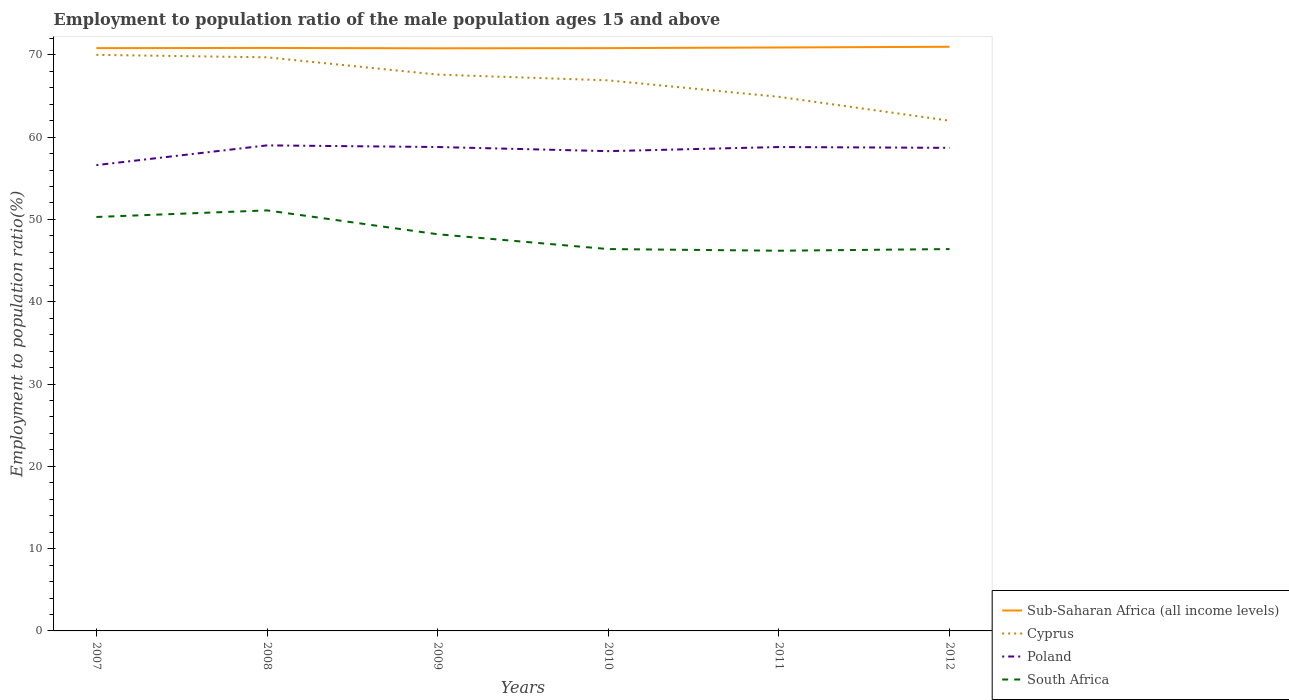How many different coloured lines are there?
Make the answer very short. 4. Is the number of lines equal to the number of legend labels?
Keep it short and to the point. Yes. Across all years, what is the maximum employment to population ratio in Poland?
Your response must be concise. 56.6. What is the total employment to population ratio in South Africa in the graph?
Keep it short and to the point. 4.7. What is the difference between the highest and the second highest employment to population ratio in Poland?
Your response must be concise. 2.4. What is the difference between the highest and the lowest employment to population ratio in Cyprus?
Your response must be concise. 4. Is the employment to population ratio in Sub-Saharan Africa (all income levels) strictly greater than the employment to population ratio in South Africa over the years?
Ensure brevity in your answer.  No. Does the graph contain any zero values?
Offer a terse response. No. Where does the legend appear in the graph?
Your response must be concise. Bottom right. How many legend labels are there?
Your answer should be compact. 4. What is the title of the graph?
Provide a succinct answer. Employment to population ratio of the male population ages 15 and above. What is the Employment to population ratio(%) in Sub-Saharan Africa (all income levels) in 2007?
Your response must be concise. 70.82. What is the Employment to population ratio(%) of Cyprus in 2007?
Make the answer very short. 70. What is the Employment to population ratio(%) of Poland in 2007?
Make the answer very short. 56.6. What is the Employment to population ratio(%) in South Africa in 2007?
Your response must be concise. 50.3. What is the Employment to population ratio(%) in Sub-Saharan Africa (all income levels) in 2008?
Keep it short and to the point. 70.84. What is the Employment to population ratio(%) of Cyprus in 2008?
Ensure brevity in your answer.  69.7. What is the Employment to population ratio(%) in Poland in 2008?
Your answer should be very brief. 59. What is the Employment to population ratio(%) in South Africa in 2008?
Provide a short and direct response. 51.1. What is the Employment to population ratio(%) in Sub-Saharan Africa (all income levels) in 2009?
Provide a short and direct response. 70.8. What is the Employment to population ratio(%) of Cyprus in 2009?
Your answer should be very brief. 67.6. What is the Employment to population ratio(%) of Poland in 2009?
Offer a very short reply. 58.8. What is the Employment to population ratio(%) in South Africa in 2009?
Give a very brief answer. 48.2. What is the Employment to population ratio(%) in Sub-Saharan Africa (all income levels) in 2010?
Offer a very short reply. 70.82. What is the Employment to population ratio(%) in Cyprus in 2010?
Provide a short and direct response. 66.9. What is the Employment to population ratio(%) in Poland in 2010?
Provide a short and direct response. 58.3. What is the Employment to population ratio(%) in South Africa in 2010?
Make the answer very short. 46.4. What is the Employment to population ratio(%) of Sub-Saharan Africa (all income levels) in 2011?
Make the answer very short. 70.9. What is the Employment to population ratio(%) in Cyprus in 2011?
Make the answer very short. 64.9. What is the Employment to population ratio(%) in Poland in 2011?
Offer a terse response. 58.8. What is the Employment to population ratio(%) in South Africa in 2011?
Make the answer very short. 46.2. What is the Employment to population ratio(%) in Sub-Saharan Africa (all income levels) in 2012?
Offer a very short reply. 70.98. What is the Employment to population ratio(%) in Poland in 2012?
Ensure brevity in your answer.  58.7. What is the Employment to population ratio(%) in South Africa in 2012?
Your answer should be compact. 46.4. Across all years, what is the maximum Employment to population ratio(%) of Sub-Saharan Africa (all income levels)?
Your answer should be compact. 70.98. Across all years, what is the maximum Employment to population ratio(%) in South Africa?
Provide a succinct answer. 51.1. Across all years, what is the minimum Employment to population ratio(%) of Sub-Saharan Africa (all income levels)?
Your answer should be compact. 70.8. Across all years, what is the minimum Employment to population ratio(%) of Poland?
Keep it short and to the point. 56.6. Across all years, what is the minimum Employment to population ratio(%) of South Africa?
Ensure brevity in your answer.  46.2. What is the total Employment to population ratio(%) in Sub-Saharan Africa (all income levels) in the graph?
Your response must be concise. 425.15. What is the total Employment to population ratio(%) in Cyprus in the graph?
Make the answer very short. 401.1. What is the total Employment to population ratio(%) of Poland in the graph?
Keep it short and to the point. 350.2. What is the total Employment to population ratio(%) of South Africa in the graph?
Ensure brevity in your answer.  288.6. What is the difference between the Employment to population ratio(%) of Sub-Saharan Africa (all income levels) in 2007 and that in 2008?
Make the answer very short. -0.02. What is the difference between the Employment to population ratio(%) of Cyprus in 2007 and that in 2008?
Your answer should be compact. 0.3. What is the difference between the Employment to population ratio(%) in Sub-Saharan Africa (all income levels) in 2007 and that in 2009?
Your response must be concise. 0.02. What is the difference between the Employment to population ratio(%) in Poland in 2007 and that in 2009?
Ensure brevity in your answer.  -2.2. What is the difference between the Employment to population ratio(%) of South Africa in 2007 and that in 2009?
Your answer should be compact. 2.1. What is the difference between the Employment to population ratio(%) of Sub-Saharan Africa (all income levels) in 2007 and that in 2010?
Give a very brief answer. -0. What is the difference between the Employment to population ratio(%) of Poland in 2007 and that in 2010?
Offer a very short reply. -1.7. What is the difference between the Employment to population ratio(%) in Sub-Saharan Africa (all income levels) in 2007 and that in 2011?
Provide a succinct answer. -0.08. What is the difference between the Employment to population ratio(%) in Cyprus in 2007 and that in 2011?
Provide a short and direct response. 5.1. What is the difference between the Employment to population ratio(%) in Poland in 2007 and that in 2011?
Make the answer very short. -2.2. What is the difference between the Employment to population ratio(%) of Sub-Saharan Africa (all income levels) in 2007 and that in 2012?
Offer a very short reply. -0.16. What is the difference between the Employment to population ratio(%) in Cyprus in 2007 and that in 2012?
Provide a succinct answer. 8. What is the difference between the Employment to population ratio(%) of Sub-Saharan Africa (all income levels) in 2008 and that in 2009?
Ensure brevity in your answer.  0.04. What is the difference between the Employment to population ratio(%) of South Africa in 2008 and that in 2009?
Offer a terse response. 2.9. What is the difference between the Employment to population ratio(%) of Sub-Saharan Africa (all income levels) in 2008 and that in 2010?
Your answer should be very brief. 0.02. What is the difference between the Employment to population ratio(%) of Cyprus in 2008 and that in 2010?
Ensure brevity in your answer.  2.8. What is the difference between the Employment to population ratio(%) in Poland in 2008 and that in 2010?
Make the answer very short. 0.7. What is the difference between the Employment to population ratio(%) of South Africa in 2008 and that in 2010?
Your response must be concise. 4.7. What is the difference between the Employment to population ratio(%) of Sub-Saharan Africa (all income levels) in 2008 and that in 2011?
Offer a terse response. -0.06. What is the difference between the Employment to population ratio(%) in Cyprus in 2008 and that in 2011?
Give a very brief answer. 4.8. What is the difference between the Employment to population ratio(%) in South Africa in 2008 and that in 2011?
Provide a succinct answer. 4.9. What is the difference between the Employment to population ratio(%) in Sub-Saharan Africa (all income levels) in 2008 and that in 2012?
Offer a terse response. -0.14. What is the difference between the Employment to population ratio(%) in Cyprus in 2008 and that in 2012?
Offer a very short reply. 7.7. What is the difference between the Employment to population ratio(%) in Poland in 2008 and that in 2012?
Your answer should be very brief. 0.3. What is the difference between the Employment to population ratio(%) of Sub-Saharan Africa (all income levels) in 2009 and that in 2010?
Give a very brief answer. -0.02. What is the difference between the Employment to population ratio(%) of Cyprus in 2009 and that in 2010?
Keep it short and to the point. 0.7. What is the difference between the Employment to population ratio(%) of Poland in 2009 and that in 2010?
Your answer should be compact. 0.5. What is the difference between the Employment to population ratio(%) in Sub-Saharan Africa (all income levels) in 2009 and that in 2011?
Provide a succinct answer. -0.1. What is the difference between the Employment to population ratio(%) of Cyprus in 2009 and that in 2011?
Give a very brief answer. 2.7. What is the difference between the Employment to population ratio(%) of Poland in 2009 and that in 2011?
Offer a very short reply. 0. What is the difference between the Employment to population ratio(%) of South Africa in 2009 and that in 2011?
Your answer should be compact. 2. What is the difference between the Employment to population ratio(%) of Sub-Saharan Africa (all income levels) in 2009 and that in 2012?
Offer a very short reply. -0.18. What is the difference between the Employment to population ratio(%) of Cyprus in 2009 and that in 2012?
Offer a very short reply. 5.6. What is the difference between the Employment to population ratio(%) in Poland in 2009 and that in 2012?
Your response must be concise. 0.1. What is the difference between the Employment to population ratio(%) of Sub-Saharan Africa (all income levels) in 2010 and that in 2011?
Your answer should be compact. -0.08. What is the difference between the Employment to population ratio(%) in Poland in 2010 and that in 2011?
Ensure brevity in your answer.  -0.5. What is the difference between the Employment to population ratio(%) in South Africa in 2010 and that in 2011?
Give a very brief answer. 0.2. What is the difference between the Employment to population ratio(%) in Sub-Saharan Africa (all income levels) in 2010 and that in 2012?
Give a very brief answer. -0.16. What is the difference between the Employment to population ratio(%) of Cyprus in 2010 and that in 2012?
Your response must be concise. 4.9. What is the difference between the Employment to population ratio(%) of Poland in 2010 and that in 2012?
Offer a very short reply. -0.4. What is the difference between the Employment to population ratio(%) of South Africa in 2010 and that in 2012?
Make the answer very short. 0. What is the difference between the Employment to population ratio(%) of Sub-Saharan Africa (all income levels) in 2011 and that in 2012?
Make the answer very short. -0.09. What is the difference between the Employment to population ratio(%) in Cyprus in 2011 and that in 2012?
Keep it short and to the point. 2.9. What is the difference between the Employment to population ratio(%) in Poland in 2011 and that in 2012?
Keep it short and to the point. 0.1. What is the difference between the Employment to population ratio(%) in Sub-Saharan Africa (all income levels) in 2007 and the Employment to population ratio(%) in Cyprus in 2008?
Offer a very short reply. 1.12. What is the difference between the Employment to population ratio(%) of Sub-Saharan Africa (all income levels) in 2007 and the Employment to population ratio(%) of Poland in 2008?
Make the answer very short. 11.82. What is the difference between the Employment to population ratio(%) in Sub-Saharan Africa (all income levels) in 2007 and the Employment to population ratio(%) in South Africa in 2008?
Provide a succinct answer. 19.72. What is the difference between the Employment to population ratio(%) in Poland in 2007 and the Employment to population ratio(%) in South Africa in 2008?
Give a very brief answer. 5.5. What is the difference between the Employment to population ratio(%) of Sub-Saharan Africa (all income levels) in 2007 and the Employment to population ratio(%) of Cyprus in 2009?
Offer a very short reply. 3.22. What is the difference between the Employment to population ratio(%) of Sub-Saharan Africa (all income levels) in 2007 and the Employment to population ratio(%) of Poland in 2009?
Provide a succinct answer. 12.02. What is the difference between the Employment to population ratio(%) in Sub-Saharan Africa (all income levels) in 2007 and the Employment to population ratio(%) in South Africa in 2009?
Give a very brief answer. 22.62. What is the difference between the Employment to population ratio(%) of Cyprus in 2007 and the Employment to population ratio(%) of South Africa in 2009?
Offer a very short reply. 21.8. What is the difference between the Employment to population ratio(%) in Sub-Saharan Africa (all income levels) in 2007 and the Employment to population ratio(%) in Cyprus in 2010?
Provide a short and direct response. 3.92. What is the difference between the Employment to population ratio(%) in Sub-Saharan Africa (all income levels) in 2007 and the Employment to population ratio(%) in Poland in 2010?
Your response must be concise. 12.52. What is the difference between the Employment to population ratio(%) in Sub-Saharan Africa (all income levels) in 2007 and the Employment to population ratio(%) in South Africa in 2010?
Make the answer very short. 24.42. What is the difference between the Employment to population ratio(%) in Cyprus in 2007 and the Employment to population ratio(%) in Poland in 2010?
Give a very brief answer. 11.7. What is the difference between the Employment to population ratio(%) of Cyprus in 2007 and the Employment to population ratio(%) of South Africa in 2010?
Make the answer very short. 23.6. What is the difference between the Employment to population ratio(%) of Poland in 2007 and the Employment to population ratio(%) of South Africa in 2010?
Provide a succinct answer. 10.2. What is the difference between the Employment to population ratio(%) in Sub-Saharan Africa (all income levels) in 2007 and the Employment to population ratio(%) in Cyprus in 2011?
Your answer should be very brief. 5.92. What is the difference between the Employment to population ratio(%) in Sub-Saharan Africa (all income levels) in 2007 and the Employment to population ratio(%) in Poland in 2011?
Your response must be concise. 12.02. What is the difference between the Employment to population ratio(%) in Sub-Saharan Africa (all income levels) in 2007 and the Employment to population ratio(%) in South Africa in 2011?
Your answer should be compact. 24.62. What is the difference between the Employment to population ratio(%) of Cyprus in 2007 and the Employment to population ratio(%) of South Africa in 2011?
Your answer should be compact. 23.8. What is the difference between the Employment to population ratio(%) in Sub-Saharan Africa (all income levels) in 2007 and the Employment to population ratio(%) in Cyprus in 2012?
Provide a succinct answer. 8.82. What is the difference between the Employment to population ratio(%) of Sub-Saharan Africa (all income levels) in 2007 and the Employment to population ratio(%) of Poland in 2012?
Provide a short and direct response. 12.12. What is the difference between the Employment to population ratio(%) in Sub-Saharan Africa (all income levels) in 2007 and the Employment to population ratio(%) in South Africa in 2012?
Offer a very short reply. 24.42. What is the difference between the Employment to population ratio(%) in Cyprus in 2007 and the Employment to population ratio(%) in South Africa in 2012?
Ensure brevity in your answer.  23.6. What is the difference between the Employment to population ratio(%) of Poland in 2007 and the Employment to population ratio(%) of South Africa in 2012?
Your answer should be very brief. 10.2. What is the difference between the Employment to population ratio(%) in Sub-Saharan Africa (all income levels) in 2008 and the Employment to population ratio(%) in Cyprus in 2009?
Make the answer very short. 3.24. What is the difference between the Employment to population ratio(%) in Sub-Saharan Africa (all income levels) in 2008 and the Employment to population ratio(%) in Poland in 2009?
Offer a very short reply. 12.04. What is the difference between the Employment to population ratio(%) in Sub-Saharan Africa (all income levels) in 2008 and the Employment to population ratio(%) in South Africa in 2009?
Your response must be concise. 22.64. What is the difference between the Employment to population ratio(%) in Cyprus in 2008 and the Employment to population ratio(%) in South Africa in 2009?
Keep it short and to the point. 21.5. What is the difference between the Employment to population ratio(%) of Sub-Saharan Africa (all income levels) in 2008 and the Employment to population ratio(%) of Cyprus in 2010?
Keep it short and to the point. 3.94. What is the difference between the Employment to population ratio(%) in Sub-Saharan Africa (all income levels) in 2008 and the Employment to population ratio(%) in Poland in 2010?
Provide a short and direct response. 12.54. What is the difference between the Employment to population ratio(%) in Sub-Saharan Africa (all income levels) in 2008 and the Employment to population ratio(%) in South Africa in 2010?
Your response must be concise. 24.44. What is the difference between the Employment to population ratio(%) of Cyprus in 2008 and the Employment to population ratio(%) of Poland in 2010?
Offer a very short reply. 11.4. What is the difference between the Employment to population ratio(%) in Cyprus in 2008 and the Employment to population ratio(%) in South Africa in 2010?
Your answer should be very brief. 23.3. What is the difference between the Employment to population ratio(%) of Poland in 2008 and the Employment to population ratio(%) of South Africa in 2010?
Your answer should be compact. 12.6. What is the difference between the Employment to population ratio(%) in Sub-Saharan Africa (all income levels) in 2008 and the Employment to population ratio(%) in Cyprus in 2011?
Your answer should be very brief. 5.94. What is the difference between the Employment to population ratio(%) of Sub-Saharan Africa (all income levels) in 2008 and the Employment to population ratio(%) of Poland in 2011?
Provide a succinct answer. 12.04. What is the difference between the Employment to population ratio(%) of Sub-Saharan Africa (all income levels) in 2008 and the Employment to population ratio(%) of South Africa in 2011?
Keep it short and to the point. 24.64. What is the difference between the Employment to population ratio(%) in Cyprus in 2008 and the Employment to population ratio(%) in Poland in 2011?
Make the answer very short. 10.9. What is the difference between the Employment to population ratio(%) in Sub-Saharan Africa (all income levels) in 2008 and the Employment to population ratio(%) in Cyprus in 2012?
Your answer should be very brief. 8.84. What is the difference between the Employment to population ratio(%) in Sub-Saharan Africa (all income levels) in 2008 and the Employment to population ratio(%) in Poland in 2012?
Ensure brevity in your answer.  12.14. What is the difference between the Employment to population ratio(%) in Sub-Saharan Africa (all income levels) in 2008 and the Employment to population ratio(%) in South Africa in 2012?
Give a very brief answer. 24.44. What is the difference between the Employment to population ratio(%) of Cyprus in 2008 and the Employment to population ratio(%) of Poland in 2012?
Keep it short and to the point. 11. What is the difference between the Employment to population ratio(%) in Cyprus in 2008 and the Employment to population ratio(%) in South Africa in 2012?
Provide a short and direct response. 23.3. What is the difference between the Employment to population ratio(%) of Poland in 2008 and the Employment to population ratio(%) of South Africa in 2012?
Your answer should be compact. 12.6. What is the difference between the Employment to population ratio(%) of Sub-Saharan Africa (all income levels) in 2009 and the Employment to population ratio(%) of Cyprus in 2010?
Your answer should be compact. 3.9. What is the difference between the Employment to population ratio(%) in Sub-Saharan Africa (all income levels) in 2009 and the Employment to population ratio(%) in Poland in 2010?
Your answer should be compact. 12.5. What is the difference between the Employment to population ratio(%) of Sub-Saharan Africa (all income levels) in 2009 and the Employment to population ratio(%) of South Africa in 2010?
Keep it short and to the point. 24.4. What is the difference between the Employment to population ratio(%) in Cyprus in 2009 and the Employment to population ratio(%) in Poland in 2010?
Keep it short and to the point. 9.3. What is the difference between the Employment to population ratio(%) of Cyprus in 2009 and the Employment to population ratio(%) of South Africa in 2010?
Your response must be concise. 21.2. What is the difference between the Employment to population ratio(%) in Poland in 2009 and the Employment to population ratio(%) in South Africa in 2010?
Provide a short and direct response. 12.4. What is the difference between the Employment to population ratio(%) in Sub-Saharan Africa (all income levels) in 2009 and the Employment to population ratio(%) in Cyprus in 2011?
Provide a succinct answer. 5.9. What is the difference between the Employment to population ratio(%) of Sub-Saharan Africa (all income levels) in 2009 and the Employment to population ratio(%) of Poland in 2011?
Keep it short and to the point. 12. What is the difference between the Employment to population ratio(%) in Sub-Saharan Africa (all income levels) in 2009 and the Employment to population ratio(%) in South Africa in 2011?
Your answer should be very brief. 24.6. What is the difference between the Employment to population ratio(%) in Cyprus in 2009 and the Employment to population ratio(%) in Poland in 2011?
Give a very brief answer. 8.8. What is the difference between the Employment to population ratio(%) in Cyprus in 2009 and the Employment to population ratio(%) in South Africa in 2011?
Keep it short and to the point. 21.4. What is the difference between the Employment to population ratio(%) of Sub-Saharan Africa (all income levels) in 2009 and the Employment to population ratio(%) of Cyprus in 2012?
Your answer should be very brief. 8.8. What is the difference between the Employment to population ratio(%) in Sub-Saharan Africa (all income levels) in 2009 and the Employment to population ratio(%) in Poland in 2012?
Provide a short and direct response. 12.1. What is the difference between the Employment to population ratio(%) of Sub-Saharan Africa (all income levels) in 2009 and the Employment to population ratio(%) of South Africa in 2012?
Your response must be concise. 24.4. What is the difference between the Employment to population ratio(%) in Cyprus in 2009 and the Employment to population ratio(%) in Poland in 2012?
Your answer should be compact. 8.9. What is the difference between the Employment to population ratio(%) in Cyprus in 2009 and the Employment to population ratio(%) in South Africa in 2012?
Give a very brief answer. 21.2. What is the difference between the Employment to population ratio(%) of Poland in 2009 and the Employment to population ratio(%) of South Africa in 2012?
Your answer should be very brief. 12.4. What is the difference between the Employment to population ratio(%) of Sub-Saharan Africa (all income levels) in 2010 and the Employment to population ratio(%) of Cyprus in 2011?
Offer a very short reply. 5.92. What is the difference between the Employment to population ratio(%) of Sub-Saharan Africa (all income levels) in 2010 and the Employment to population ratio(%) of Poland in 2011?
Provide a succinct answer. 12.02. What is the difference between the Employment to population ratio(%) of Sub-Saharan Africa (all income levels) in 2010 and the Employment to population ratio(%) of South Africa in 2011?
Offer a very short reply. 24.62. What is the difference between the Employment to population ratio(%) in Cyprus in 2010 and the Employment to population ratio(%) in Poland in 2011?
Your response must be concise. 8.1. What is the difference between the Employment to population ratio(%) in Cyprus in 2010 and the Employment to population ratio(%) in South Africa in 2011?
Your answer should be very brief. 20.7. What is the difference between the Employment to population ratio(%) in Sub-Saharan Africa (all income levels) in 2010 and the Employment to population ratio(%) in Cyprus in 2012?
Your answer should be very brief. 8.82. What is the difference between the Employment to population ratio(%) in Sub-Saharan Africa (all income levels) in 2010 and the Employment to population ratio(%) in Poland in 2012?
Provide a short and direct response. 12.12. What is the difference between the Employment to population ratio(%) in Sub-Saharan Africa (all income levels) in 2010 and the Employment to population ratio(%) in South Africa in 2012?
Offer a terse response. 24.42. What is the difference between the Employment to population ratio(%) of Poland in 2010 and the Employment to population ratio(%) of South Africa in 2012?
Provide a short and direct response. 11.9. What is the difference between the Employment to population ratio(%) in Sub-Saharan Africa (all income levels) in 2011 and the Employment to population ratio(%) in Cyprus in 2012?
Offer a very short reply. 8.9. What is the difference between the Employment to population ratio(%) of Sub-Saharan Africa (all income levels) in 2011 and the Employment to population ratio(%) of Poland in 2012?
Give a very brief answer. 12.2. What is the difference between the Employment to population ratio(%) in Sub-Saharan Africa (all income levels) in 2011 and the Employment to population ratio(%) in South Africa in 2012?
Your answer should be compact. 24.5. What is the average Employment to population ratio(%) in Sub-Saharan Africa (all income levels) per year?
Keep it short and to the point. 70.86. What is the average Employment to population ratio(%) in Cyprus per year?
Keep it short and to the point. 66.85. What is the average Employment to population ratio(%) in Poland per year?
Your answer should be compact. 58.37. What is the average Employment to population ratio(%) in South Africa per year?
Keep it short and to the point. 48.1. In the year 2007, what is the difference between the Employment to population ratio(%) in Sub-Saharan Africa (all income levels) and Employment to population ratio(%) in Cyprus?
Make the answer very short. 0.82. In the year 2007, what is the difference between the Employment to population ratio(%) of Sub-Saharan Africa (all income levels) and Employment to population ratio(%) of Poland?
Your response must be concise. 14.22. In the year 2007, what is the difference between the Employment to population ratio(%) of Sub-Saharan Africa (all income levels) and Employment to population ratio(%) of South Africa?
Provide a succinct answer. 20.52. In the year 2008, what is the difference between the Employment to population ratio(%) in Sub-Saharan Africa (all income levels) and Employment to population ratio(%) in Cyprus?
Your answer should be very brief. 1.14. In the year 2008, what is the difference between the Employment to population ratio(%) of Sub-Saharan Africa (all income levels) and Employment to population ratio(%) of Poland?
Your answer should be very brief. 11.84. In the year 2008, what is the difference between the Employment to population ratio(%) in Sub-Saharan Africa (all income levels) and Employment to population ratio(%) in South Africa?
Ensure brevity in your answer.  19.74. In the year 2008, what is the difference between the Employment to population ratio(%) of Cyprus and Employment to population ratio(%) of Poland?
Keep it short and to the point. 10.7. In the year 2009, what is the difference between the Employment to population ratio(%) in Sub-Saharan Africa (all income levels) and Employment to population ratio(%) in Cyprus?
Provide a succinct answer. 3.2. In the year 2009, what is the difference between the Employment to population ratio(%) of Sub-Saharan Africa (all income levels) and Employment to population ratio(%) of Poland?
Ensure brevity in your answer.  12. In the year 2009, what is the difference between the Employment to population ratio(%) in Sub-Saharan Africa (all income levels) and Employment to population ratio(%) in South Africa?
Ensure brevity in your answer.  22.6. In the year 2009, what is the difference between the Employment to population ratio(%) in Cyprus and Employment to population ratio(%) in South Africa?
Offer a very short reply. 19.4. In the year 2009, what is the difference between the Employment to population ratio(%) of Poland and Employment to population ratio(%) of South Africa?
Your answer should be compact. 10.6. In the year 2010, what is the difference between the Employment to population ratio(%) of Sub-Saharan Africa (all income levels) and Employment to population ratio(%) of Cyprus?
Make the answer very short. 3.92. In the year 2010, what is the difference between the Employment to population ratio(%) of Sub-Saharan Africa (all income levels) and Employment to population ratio(%) of Poland?
Provide a short and direct response. 12.52. In the year 2010, what is the difference between the Employment to population ratio(%) of Sub-Saharan Africa (all income levels) and Employment to population ratio(%) of South Africa?
Give a very brief answer. 24.42. In the year 2010, what is the difference between the Employment to population ratio(%) of Cyprus and Employment to population ratio(%) of South Africa?
Offer a very short reply. 20.5. In the year 2011, what is the difference between the Employment to population ratio(%) in Sub-Saharan Africa (all income levels) and Employment to population ratio(%) in Cyprus?
Provide a short and direct response. 6. In the year 2011, what is the difference between the Employment to population ratio(%) of Sub-Saharan Africa (all income levels) and Employment to population ratio(%) of Poland?
Your answer should be compact. 12.1. In the year 2011, what is the difference between the Employment to population ratio(%) in Sub-Saharan Africa (all income levels) and Employment to population ratio(%) in South Africa?
Your response must be concise. 24.7. In the year 2011, what is the difference between the Employment to population ratio(%) of Cyprus and Employment to population ratio(%) of Poland?
Ensure brevity in your answer.  6.1. In the year 2011, what is the difference between the Employment to population ratio(%) in Poland and Employment to population ratio(%) in South Africa?
Your answer should be very brief. 12.6. In the year 2012, what is the difference between the Employment to population ratio(%) of Sub-Saharan Africa (all income levels) and Employment to population ratio(%) of Cyprus?
Offer a terse response. 8.98. In the year 2012, what is the difference between the Employment to population ratio(%) in Sub-Saharan Africa (all income levels) and Employment to population ratio(%) in Poland?
Your answer should be compact. 12.28. In the year 2012, what is the difference between the Employment to population ratio(%) of Sub-Saharan Africa (all income levels) and Employment to population ratio(%) of South Africa?
Offer a very short reply. 24.58. In the year 2012, what is the difference between the Employment to population ratio(%) in Cyprus and Employment to population ratio(%) in South Africa?
Ensure brevity in your answer.  15.6. What is the ratio of the Employment to population ratio(%) of Poland in 2007 to that in 2008?
Provide a succinct answer. 0.96. What is the ratio of the Employment to population ratio(%) of South Africa in 2007 to that in 2008?
Ensure brevity in your answer.  0.98. What is the ratio of the Employment to population ratio(%) of Cyprus in 2007 to that in 2009?
Offer a terse response. 1.04. What is the ratio of the Employment to population ratio(%) of Poland in 2007 to that in 2009?
Offer a terse response. 0.96. What is the ratio of the Employment to population ratio(%) of South Africa in 2007 to that in 2009?
Your answer should be compact. 1.04. What is the ratio of the Employment to population ratio(%) in Sub-Saharan Africa (all income levels) in 2007 to that in 2010?
Your answer should be compact. 1. What is the ratio of the Employment to population ratio(%) of Cyprus in 2007 to that in 2010?
Provide a short and direct response. 1.05. What is the ratio of the Employment to population ratio(%) in Poland in 2007 to that in 2010?
Ensure brevity in your answer.  0.97. What is the ratio of the Employment to population ratio(%) in South Africa in 2007 to that in 2010?
Give a very brief answer. 1.08. What is the ratio of the Employment to population ratio(%) in Cyprus in 2007 to that in 2011?
Provide a succinct answer. 1.08. What is the ratio of the Employment to population ratio(%) of Poland in 2007 to that in 2011?
Your answer should be very brief. 0.96. What is the ratio of the Employment to population ratio(%) in South Africa in 2007 to that in 2011?
Offer a very short reply. 1.09. What is the ratio of the Employment to population ratio(%) in Cyprus in 2007 to that in 2012?
Your answer should be compact. 1.13. What is the ratio of the Employment to population ratio(%) of Poland in 2007 to that in 2012?
Your answer should be very brief. 0.96. What is the ratio of the Employment to population ratio(%) in South Africa in 2007 to that in 2012?
Your response must be concise. 1.08. What is the ratio of the Employment to population ratio(%) in Cyprus in 2008 to that in 2009?
Your answer should be compact. 1.03. What is the ratio of the Employment to population ratio(%) of Poland in 2008 to that in 2009?
Your response must be concise. 1. What is the ratio of the Employment to population ratio(%) in South Africa in 2008 to that in 2009?
Offer a very short reply. 1.06. What is the ratio of the Employment to population ratio(%) of Cyprus in 2008 to that in 2010?
Provide a short and direct response. 1.04. What is the ratio of the Employment to population ratio(%) of Poland in 2008 to that in 2010?
Provide a short and direct response. 1.01. What is the ratio of the Employment to population ratio(%) in South Africa in 2008 to that in 2010?
Your answer should be compact. 1.1. What is the ratio of the Employment to population ratio(%) in Sub-Saharan Africa (all income levels) in 2008 to that in 2011?
Offer a very short reply. 1. What is the ratio of the Employment to population ratio(%) in Cyprus in 2008 to that in 2011?
Make the answer very short. 1.07. What is the ratio of the Employment to population ratio(%) in South Africa in 2008 to that in 2011?
Your response must be concise. 1.11. What is the ratio of the Employment to population ratio(%) in Sub-Saharan Africa (all income levels) in 2008 to that in 2012?
Provide a succinct answer. 1. What is the ratio of the Employment to population ratio(%) of Cyprus in 2008 to that in 2012?
Make the answer very short. 1.12. What is the ratio of the Employment to population ratio(%) in Poland in 2008 to that in 2012?
Provide a short and direct response. 1.01. What is the ratio of the Employment to population ratio(%) in South Africa in 2008 to that in 2012?
Keep it short and to the point. 1.1. What is the ratio of the Employment to population ratio(%) in Cyprus in 2009 to that in 2010?
Ensure brevity in your answer.  1.01. What is the ratio of the Employment to population ratio(%) of Poland in 2009 to that in 2010?
Ensure brevity in your answer.  1.01. What is the ratio of the Employment to population ratio(%) in South Africa in 2009 to that in 2010?
Make the answer very short. 1.04. What is the ratio of the Employment to population ratio(%) in Cyprus in 2009 to that in 2011?
Make the answer very short. 1.04. What is the ratio of the Employment to population ratio(%) of Poland in 2009 to that in 2011?
Give a very brief answer. 1. What is the ratio of the Employment to population ratio(%) in South Africa in 2009 to that in 2011?
Your answer should be very brief. 1.04. What is the ratio of the Employment to population ratio(%) of Sub-Saharan Africa (all income levels) in 2009 to that in 2012?
Provide a succinct answer. 1. What is the ratio of the Employment to population ratio(%) of Cyprus in 2009 to that in 2012?
Your response must be concise. 1.09. What is the ratio of the Employment to population ratio(%) of South Africa in 2009 to that in 2012?
Offer a terse response. 1.04. What is the ratio of the Employment to population ratio(%) of Sub-Saharan Africa (all income levels) in 2010 to that in 2011?
Ensure brevity in your answer.  1. What is the ratio of the Employment to population ratio(%) of Cyprus in 2010 to that in 2011?
Your answer should be very brief. 1.03. What is the ratio of the Employment to population ratio(%) in South Africa in 2010 to that in 2011?
Provide a succinct answer. 1. What is the ratio of the Employment to population ratio(%) in Sub-Saharan Africa (all income levels) in 2010 to that in 2012?
Offer a terse response. 1. What is the ratio of the Employment to population ratio(%) in Cyprus in 2010 to that in 2012?
Make the answer very short. 1.08. What is the ratio of the Employment to population ratio(%) of Poland in 2010 to that in 2012?
Your answer should be compact. 0.99. What is the ratio of the Employment to population ratio(%) of South Africa in 2010 to that in 2012?
Your answer should be compact. 1. What is the ratio of the Employment to population ratio(%) of Sub-Saharan Africa (all income levels) in 2011 to that in 2012?
Keep it short and to the point. 1. What is the ratio of the Employment to population ratio(%) of Cyprus in 2011 to that in 2012?
Your response must be concise. 1.05. What is the ratio of the Employment to population ratio(%) of Poland in 2011 to that in 2012?
Keep it short and to the point. 1. What is the difference between the highest and the second highest Employment to population ratio(%) in Sub-Saharan Africa (all income levels)?
Make the answer very short. 0.09. What is the difference between the highest and the second highest Employment to population ratio(%) of Poland?
Your response must be concise. 0.2. What is the difference between the highest and the lowest Employment to population ratio(%) of Sub-Saharan Africa (all income levels)?
Offer a terse response. 0.18. What is the difference between the highest and the lowest Employment to population ratio(%) in Cyprus?
Keep it short and to the point. 8. What is the difference between the highest and the lowest Employment to population ratio(%) in South Africa?
Offer a very short reply. 4.9. 